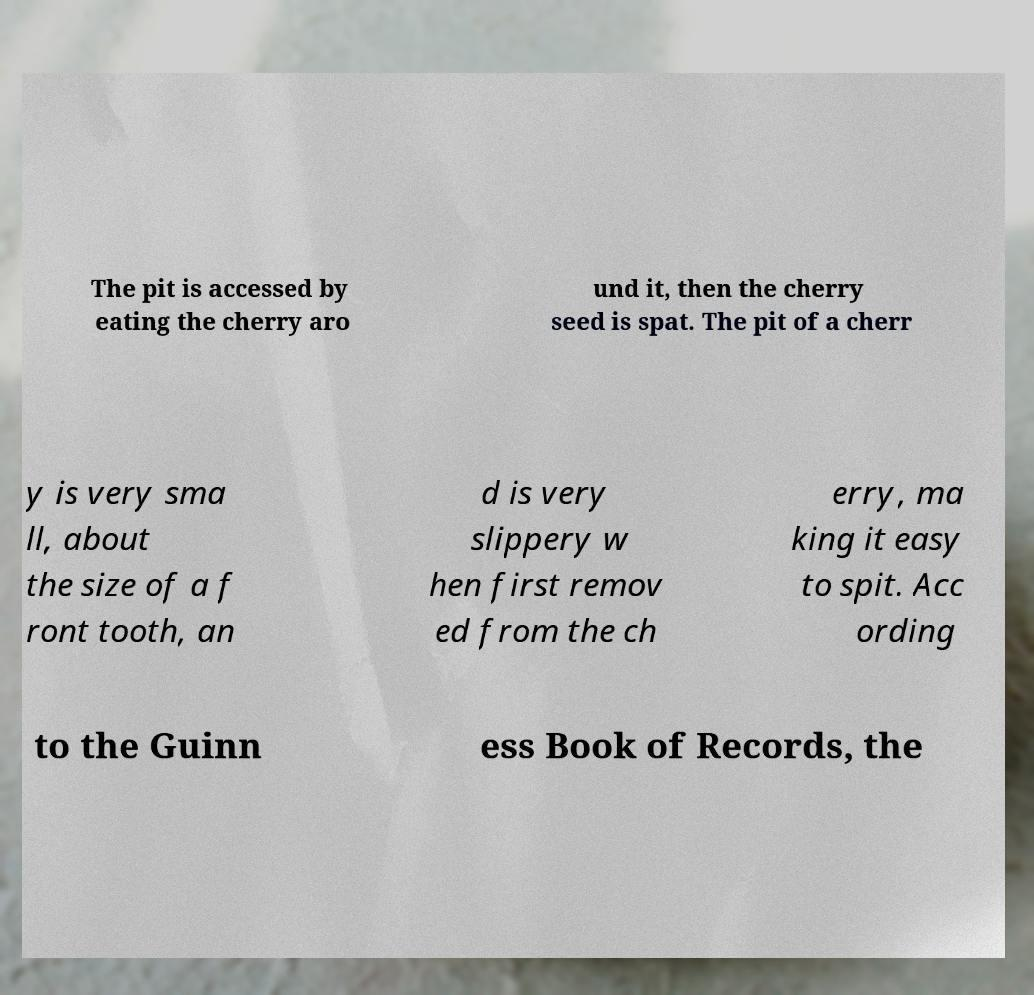What messages or text are displayed in this image? I need them in a readable, typed format. The pit is accessed by eating the cherry aro und it, then the cherry seed is spat. The pit of a cherr y is very sma ll, about the size of a f ront tooth, an d is very slippery w hen first remov ed from the ch erry, ma king it easy to spit. Acc ording to the Guinn ess Book of Records, the 